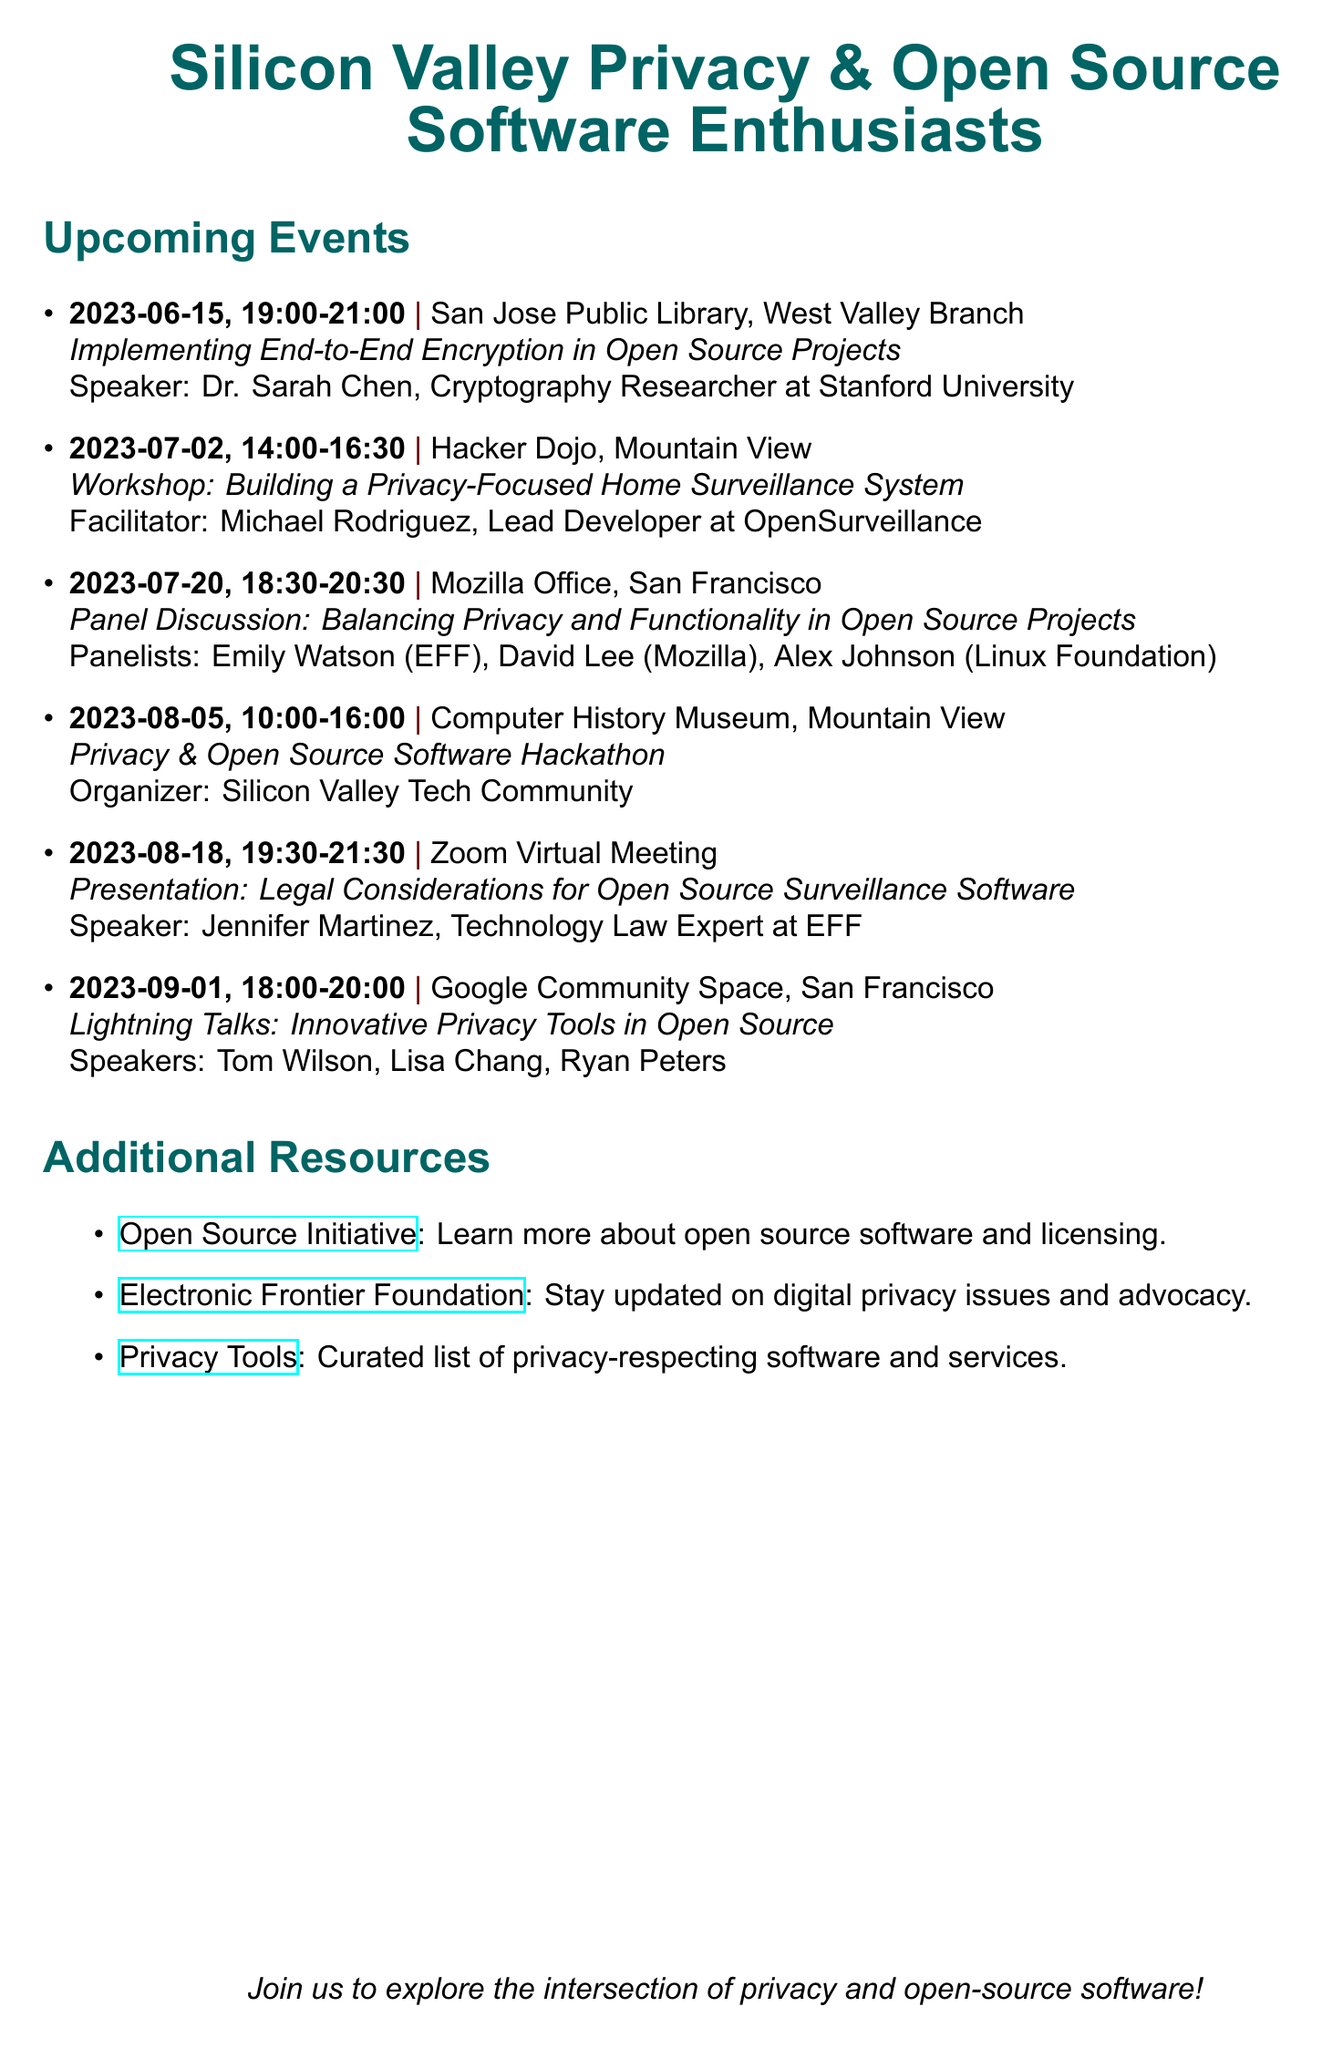What is the title of the meetup? The title of the meetup is provided at the beginning of the document as "Silicon Valley Privacy & Open Source Software Enthusiasts."
Answer: Silicon Valley Privacy & Open Source Software Enthusiasts When is the workshop on building a privacy-focused home surveillance system? The date and time for the workshop is listed, stating it occurs on July 2, 2023, from 14:00 to 16:30.
Answer: July 2, 2023 Who is the speaker for the presentation on legal considerations for open-source surveillance software? The speaker's name is mentioned in the details of the presentation, indicating Jennifer Martinez is the expert discussing legal issues.
Answer: Jennifer Martinez What is the main focus of the 2023-08-05 event? The event title and description clarify that the main focus is on privacy-enhancing features in open-source projects during a hackathon.
Answer: Privacy & Open Source Software Hackathon How many panelists are featured in the panel discussion on July 20, 2023? Analyzing the panel discussion section shows there are three listed panelists participating in this event.
Answer: Three What location will the lightning talks on September 1, 2023, be held? The document specifies Google Community Space in San Francisco as the location for the lightning talks.
Answer: Google Community Space, San Francisco Who is the facilitator for the workshop on July 2? The facilitator's name is provided in the description for the workshop, identifying Michael Rodriguez as the lead developer.
Answer: Michael Rodriguez What is the duration of the event on July 20, 2023? The duration is indicated by the start and end time, defining it as a two-hour event from 18:30 to 20:30.
Answer: Two hours What type of event is scheduled for August 18, 2023? Describing the nature of the event, the document states it is a presentation focusing on legal aspects of surveillance software.
Answer: Presentation 